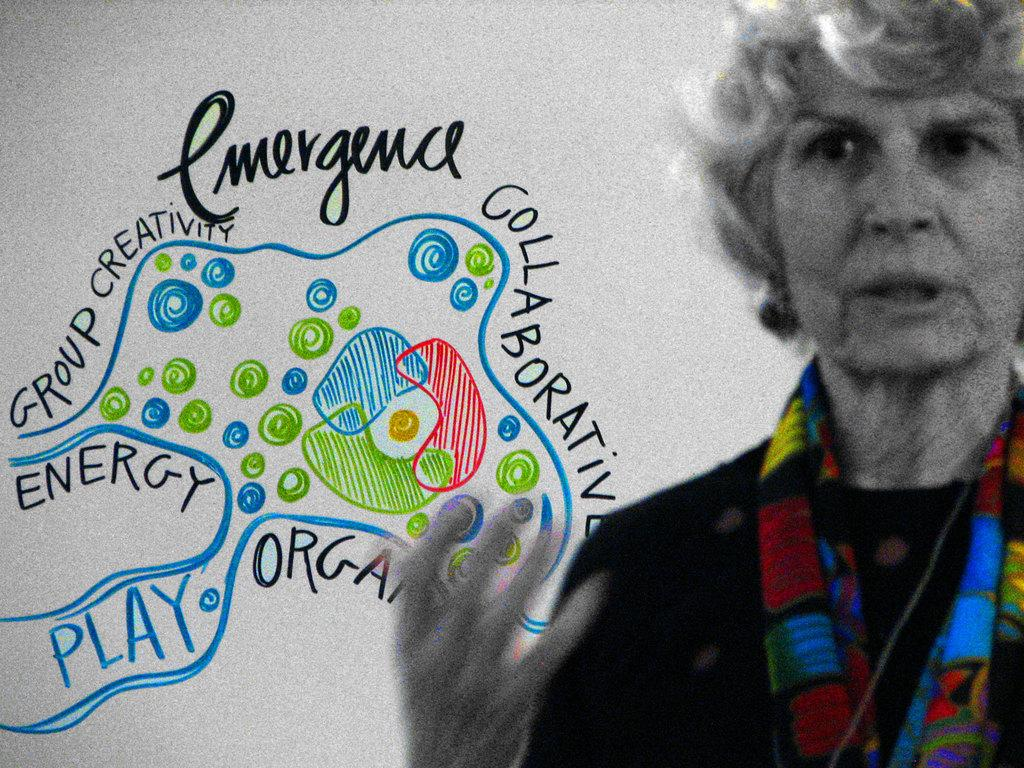Who is present in the image? There is a woman in the image. What is the color of the surface that is visible in the image? There is a white surface in the image. What is depicted on the white surface? There is a drawing on the white surface. What else is present on the white surface besides the drawing? There is some text on the white surface. What day of the week is it according to the calendar in the image? There is no calendar present in the image. What type of board is being used by the woman in the image? There is no board visible in the image. 